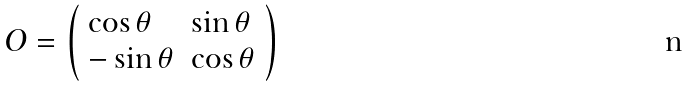<formula> <loc_0><loc_0><loc_500><loc_500>O = \left ( \begin{array} { l l } { \cos \theta } & { \sin \theta } \\ { - \sin \theta } & { \cos \theta } \end{array} \right )</formula> 